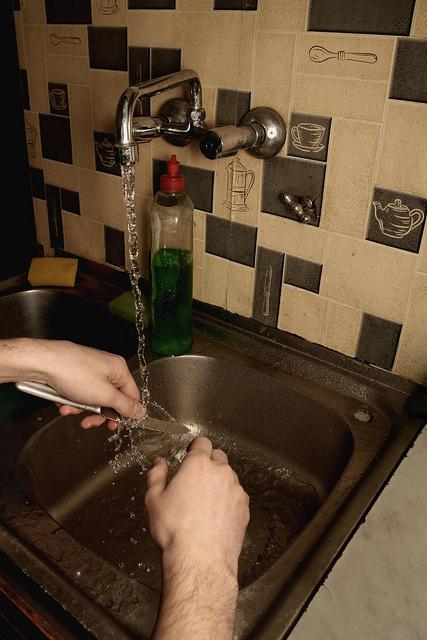What is in the container near the sink?
Answer briefly. Soap. What color is the liquid in the bottle?
Write a very short answer. Green. What is coming out of the faucet on the wall?
Concise answer only. Water. 